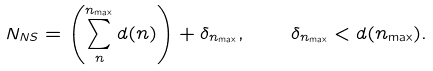Convert formula to latex. <formula><loc_0><loc_0><loc_500><loc_500>N _ { N S } = \left ( \sum _ { n } ^ { n _ { \max } } d ( n ) \right ) + \delta _ { n _ { \max } } , \quad \delta _ { n _ { \max } } < d ( n _ { \max } ) .</formula> 